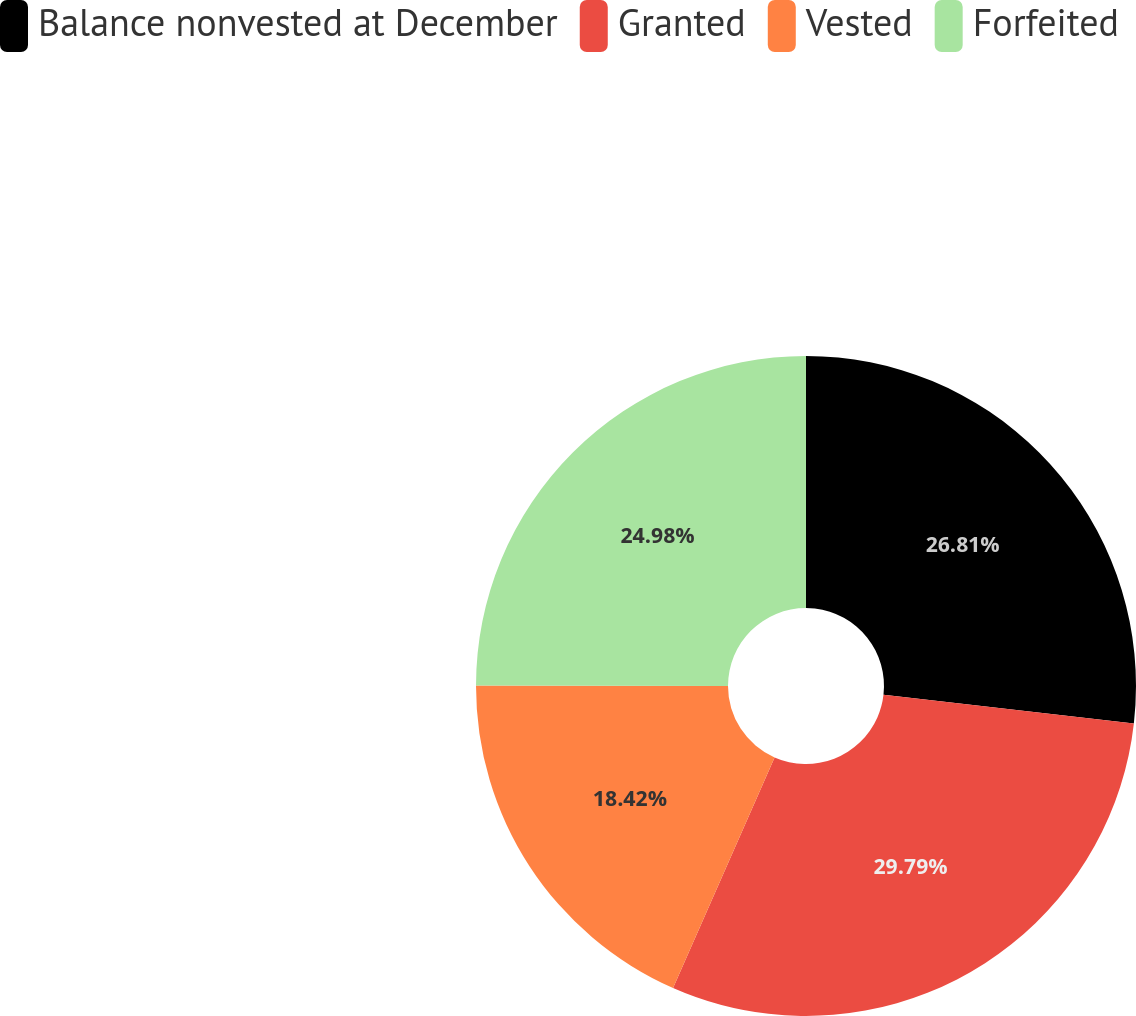Convert chart to OTSL. <chart><loc_0><loc_0><loc_500><loc_500><pie_chart><fcel>Balance nonvested at December<fcel>Granted<fcel>Vested<fcel>Forfeited<nl><fcel>26.81%<fcel>29.79%<fcel>18.42%<fcel>24.98%<nl></chart> 